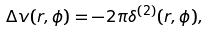<formula> <loc_0><loc_0><loc_500><loc_500>\Delta v ( r , \phi ) = - 2 \pi \delta ^ { ( 2 ) } ( r , \phi ) ,</formula> 